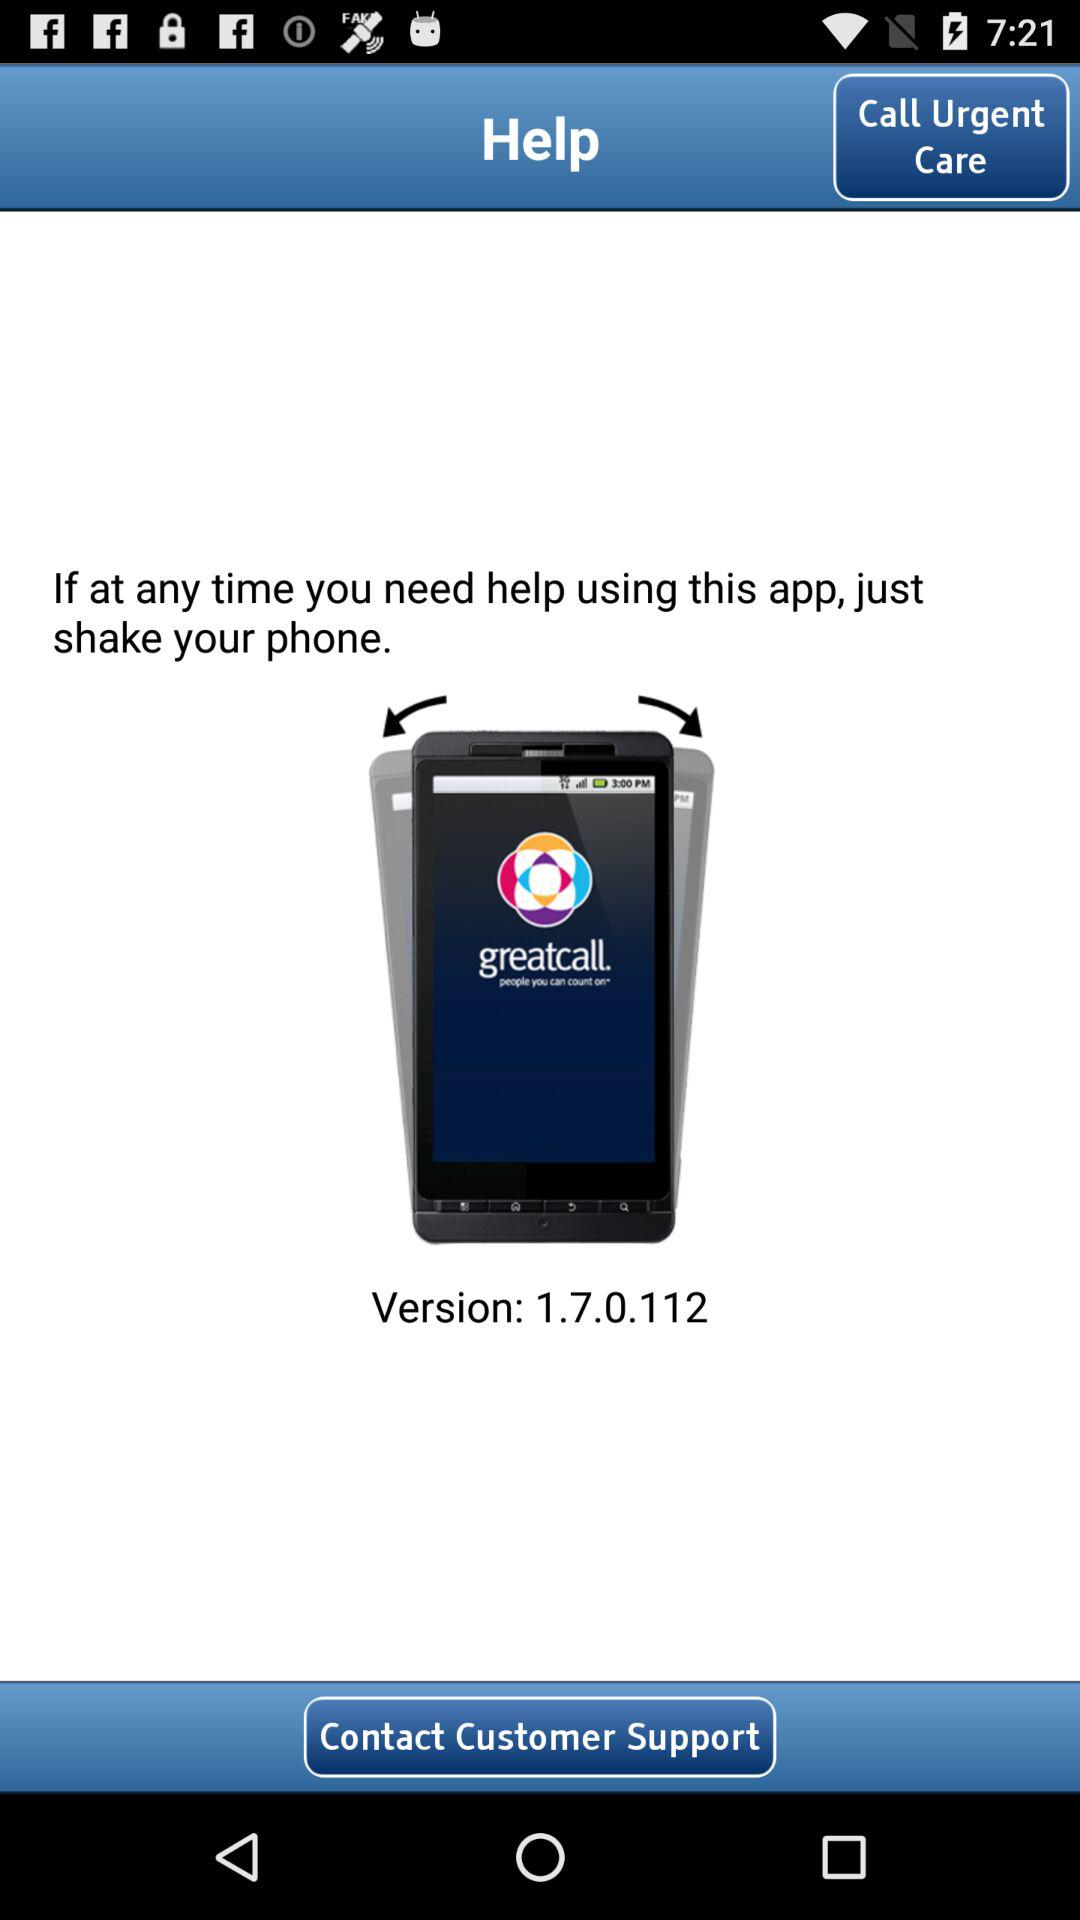What is the version of the application? The version of the application is 1.7.0.112. 